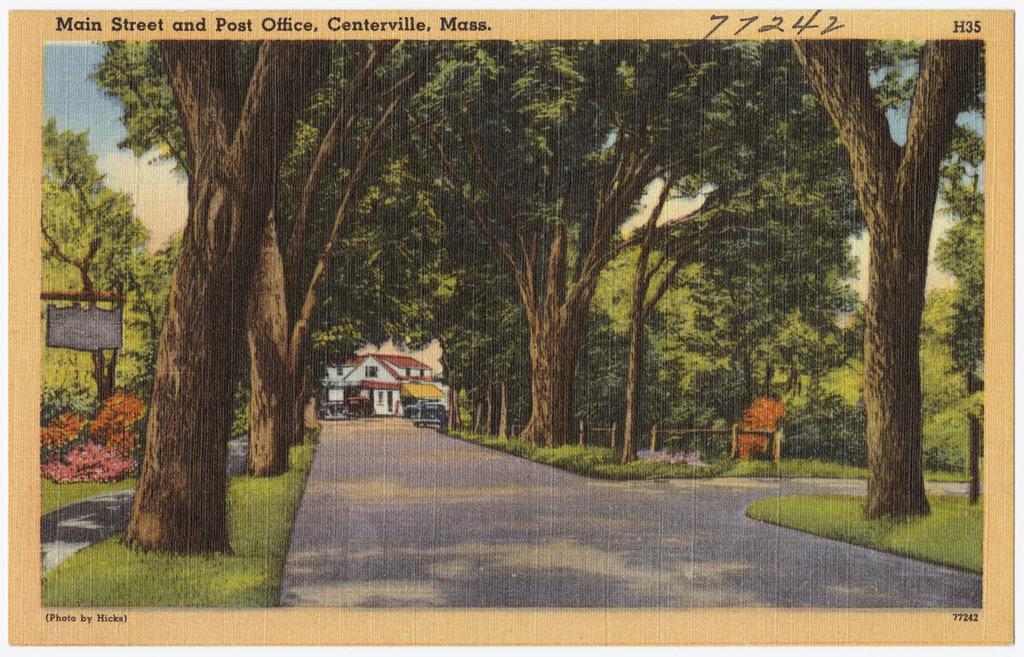Can you describe this image briefly? In the picture we can see a painting of the road and on the either sides of the road we can see grass path and trees on it and in the background, we can see a house and at the top of the tree we can see a part of the sky with clouds, and on the top of the painting it is written as main street and post office, Centerville, Mass. 